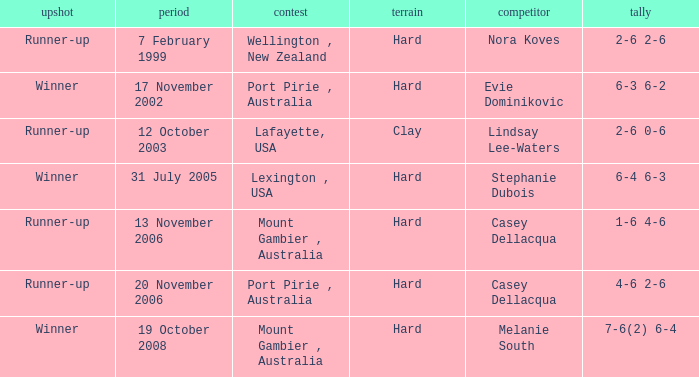Which Tournament has an Outcome of winner on 19 october 2008? Mount Gambier , Australia. 